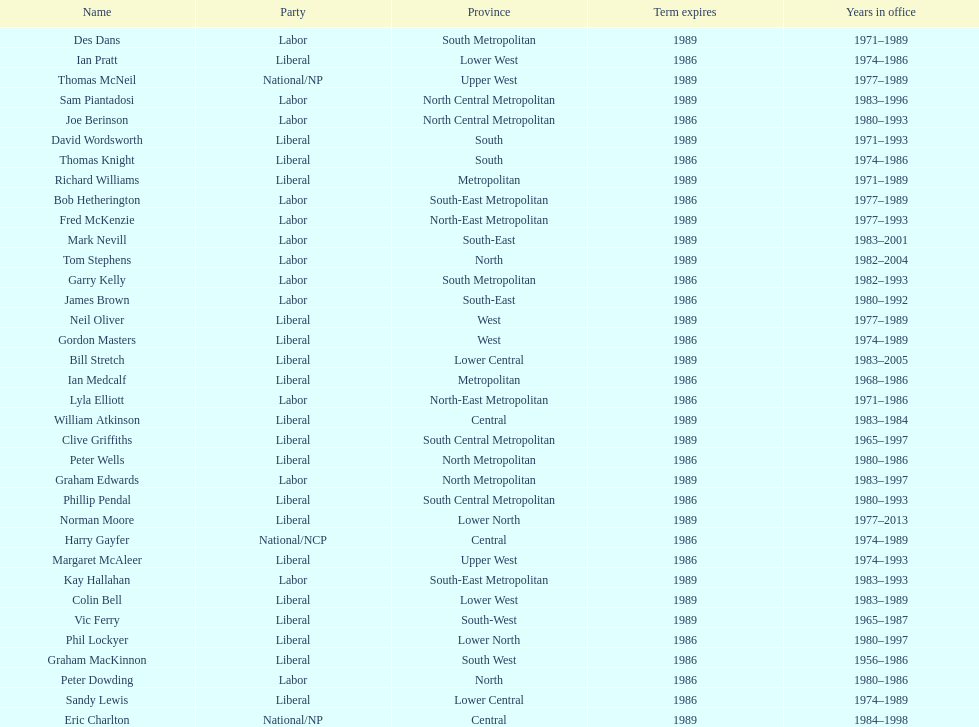Who is the final person mentioned with a last name starting with "p"? Ian Pratt. 